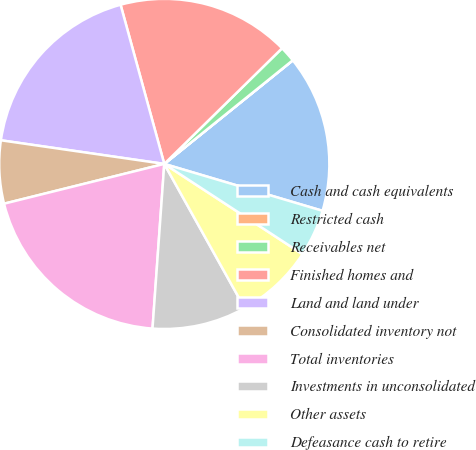Convert chart to OTSL. <chart><loc_0><loc_0><loc_500><loc_500><pie_chart><fcel>Cash and cash equivalents<fcel>Restricted cash<fcel>Receivables net<fcel>Finished homes and<fcel>Land and land under<fcel>Consolidated inventory not<fcel>Total inventories<fcel>Investments in unconsolidated<fcel>Other assets<fcel>Defeasance cash to retire<nl><fcel>15.38%<fcel>0.01%<fcel>1.55%<fcel>16.91%<fcel>18.45%<fcel>6.16%<fcel>19.99%<fcel>9.23%<fcel>7.7%<fcel>4.62%<nl></chart> 